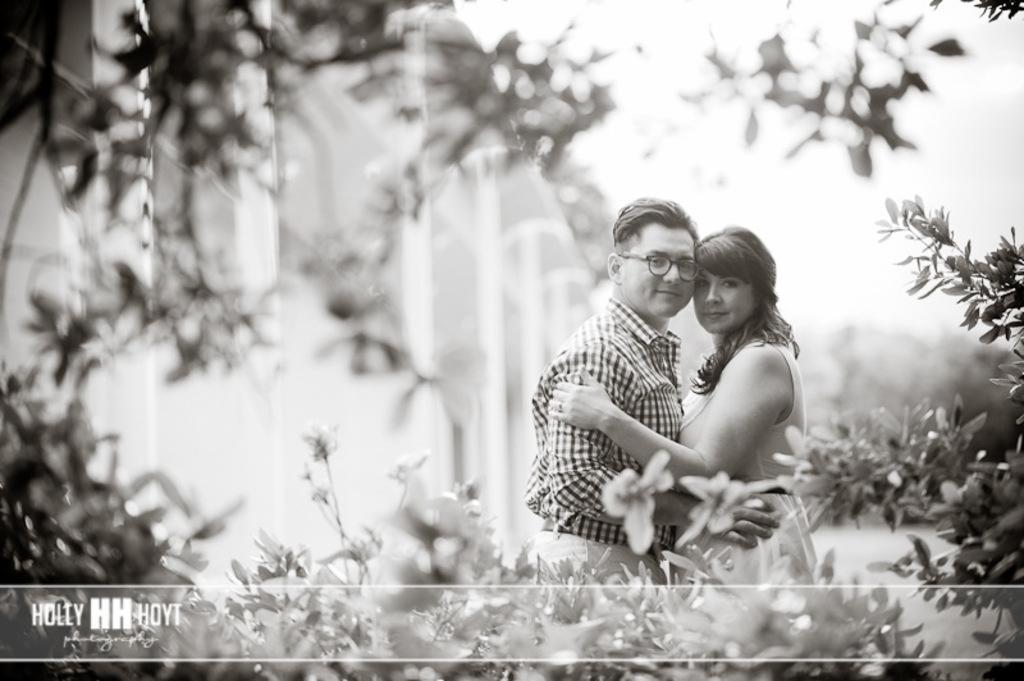In one or two sentences, can you explain what this image depicts? Black and white picture. Here we can see two people and plants. Bottom of the image there is a watermark. Background it is blur. 